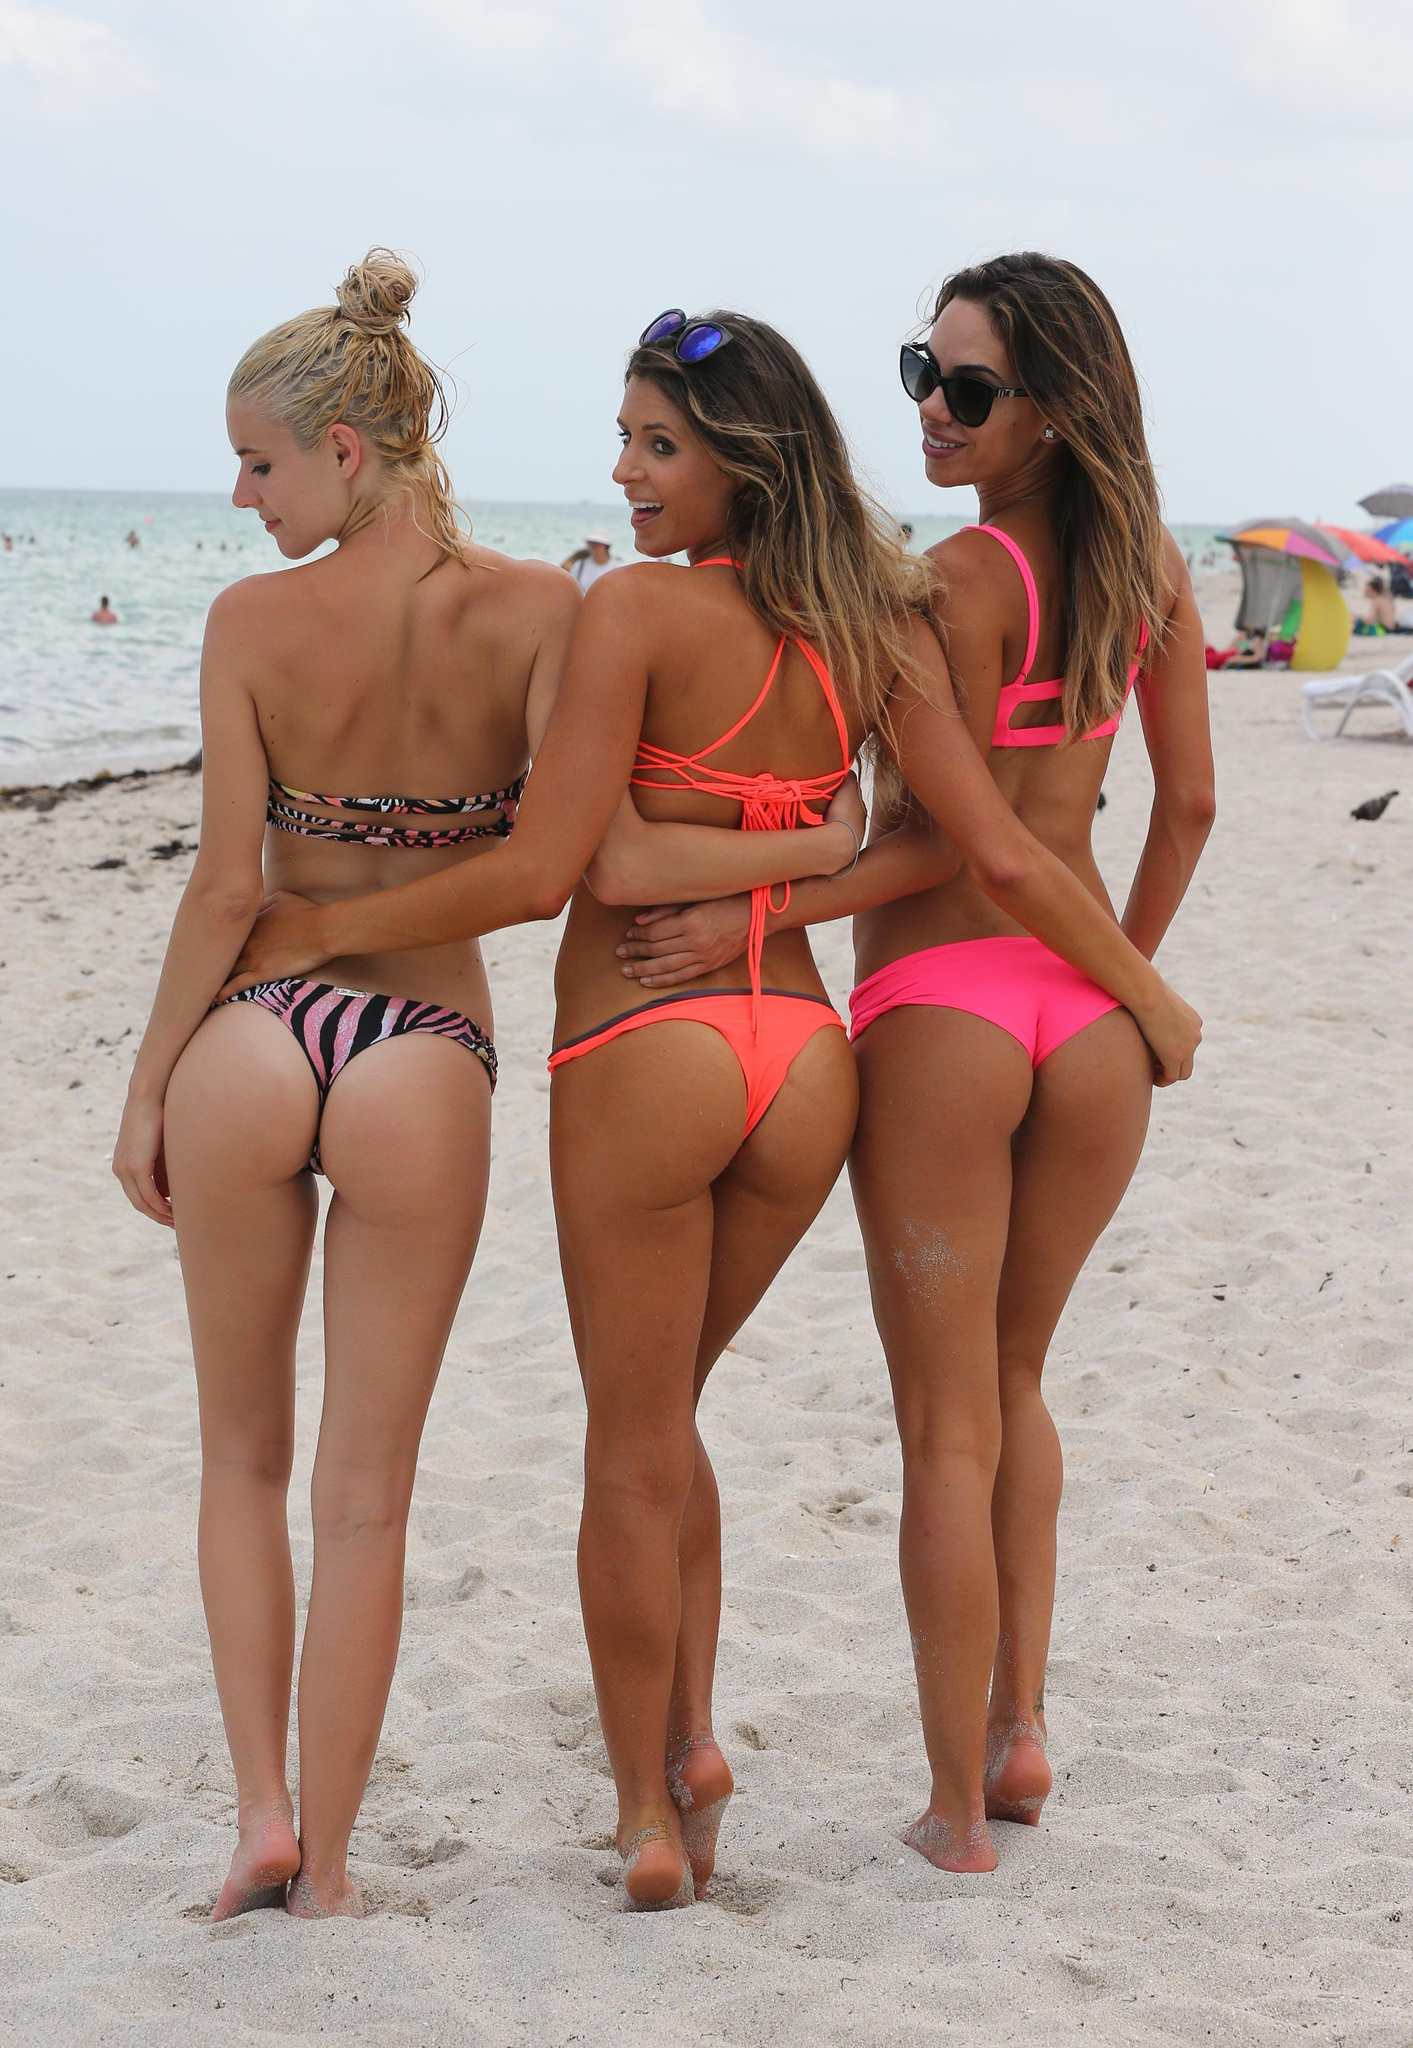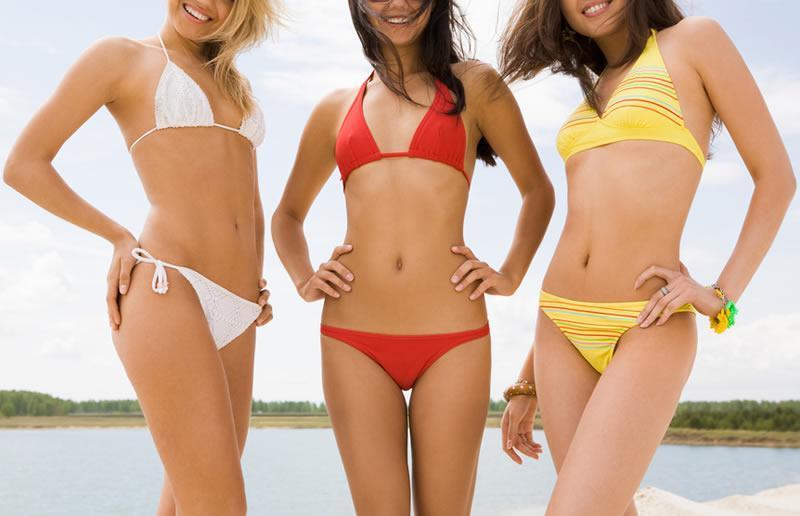The first image is the image on the left, the second image is the image on the right. Given the left and right images, does the statement "Three girls pose together for the picture wearing bikinis." hold true? Answer yes or no. Yes. The first image is the image on the left, the second image is the image on the right. Considering the images on both sides, is "There are six women wearing swimsuits." valid? Answer yes or no. Yes. 